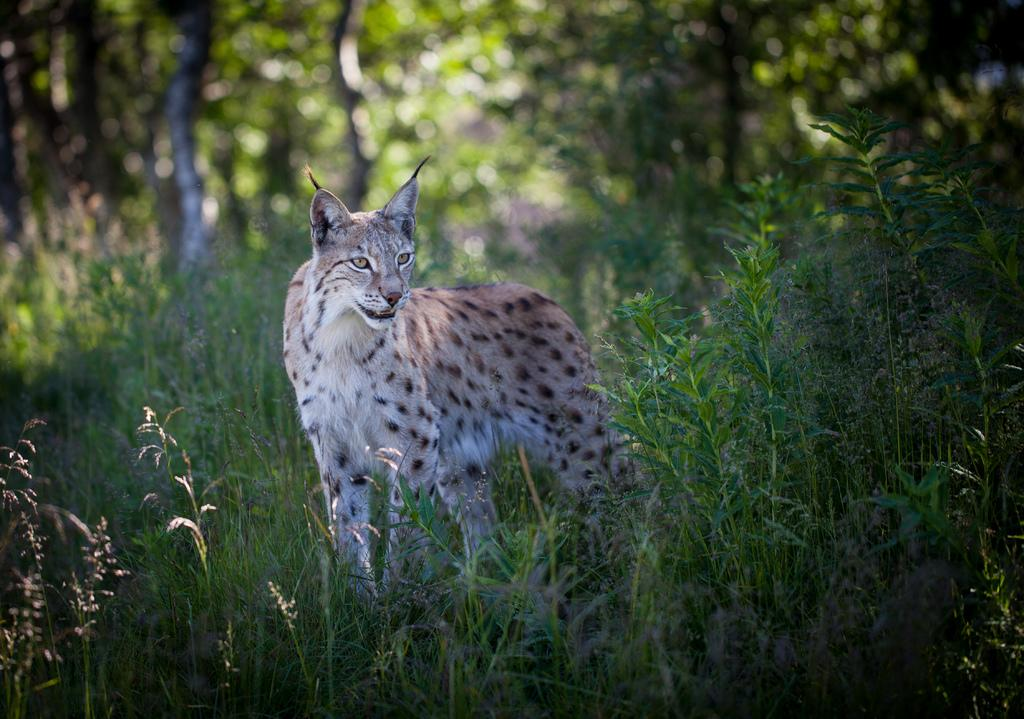What is the main subject in the center of the image? There is an animal in the center of the image. What can be seen at the bottom of the image? There are plants at the bottom of the image. What type of vegetation is visible in the background of the image? There are trees in the background of the image. What type of suit is the father wearing in the image? There is no father or suit present in the image. 